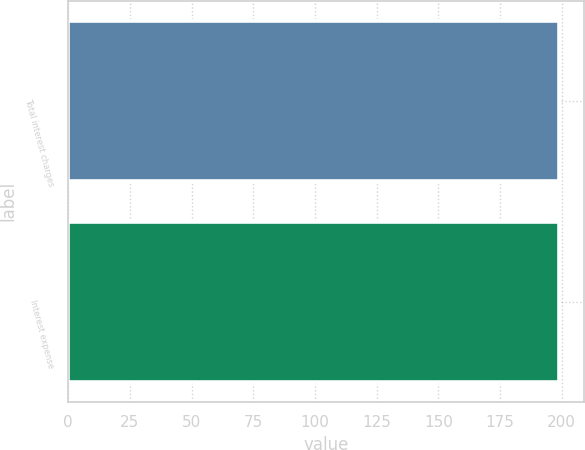Convert chart. <chart><loc_0><loc_0><loc_500><loc_500><bar_chart><fcel>Total interest charges<fcel>Interest expense<nl><fcel>199<fcel>199.1<nl></chart> 